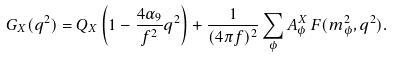<formula> <loc_0><loc_0><loc_500><loc_500>G _ { X } ( q ^ { 2 } ) = Q _ { X } \left ( 1 - \frac { 4 \alpha _ { 9 } } { f ^ { 2 } } q ^ { 2 } \right ) + \frac { 1 } { ( 4 \pi f ) ^ { 2 } } \sum _ { \phi } A ^ { X } _ { \phi } \, F ( m _ { \phi } ^ { 2 } , q ^ { 2 } ) .</formula> 